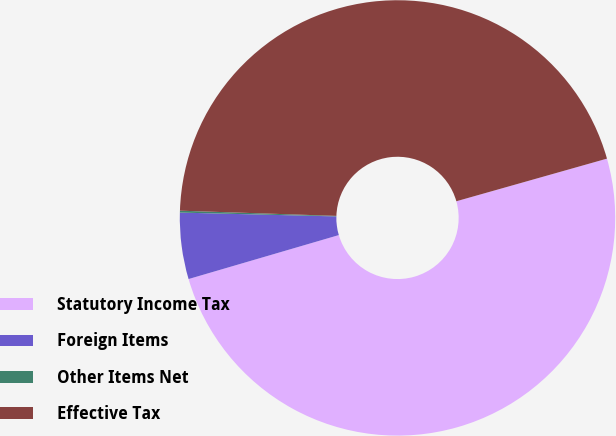Convert chart. <chart><loc_0><loc_0><loc_500><loc_500><pie_chart><fcel>Statutory Income Tax<fcel>Foreign Items<fcel>Other Items Net<fcel>Effective Tax<nl><fcel>49.86%<fcel>4.92%<fcel>0.14%<fcel>45.08%<nl></chart> 